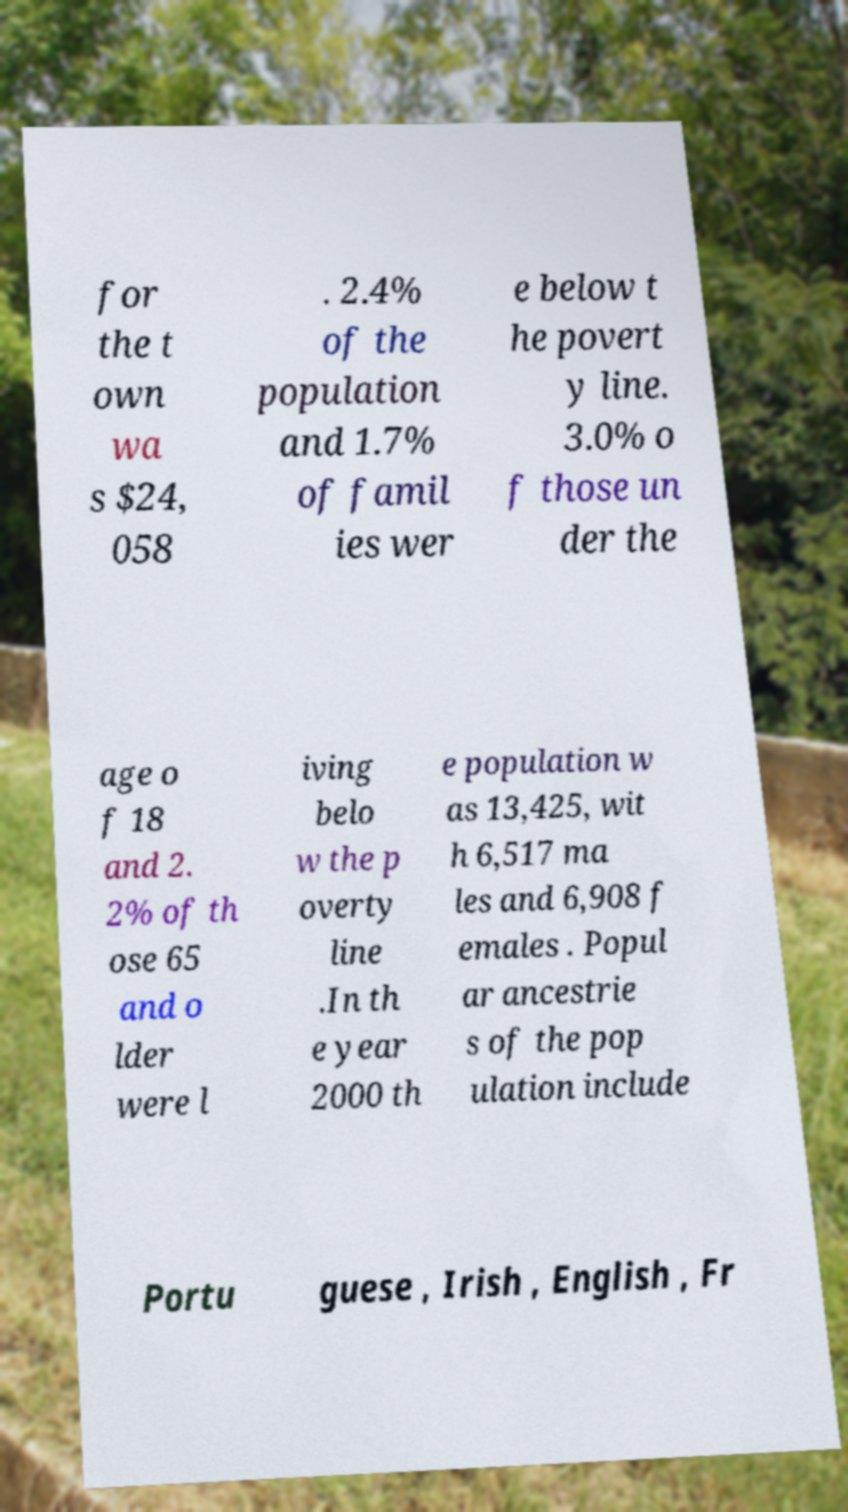What messages or text are displayed in this image? I need them in a readable, typed format. for the t own wa s $24, 058 . 2.4% of the population and 1.7% of famil ies wer e below t he povert y line. 3.0% o f those un der the age o f 18 and 2. 2% of th ose 65 and o lder were l iving belo w the p overty line .In th e year 2000 th e population w as 13,425, wit h 6,517 ma les and 6,908 f emales . Popul ar ancestrie s of the pop ulation include Portu guese , Irish , English , Fr 